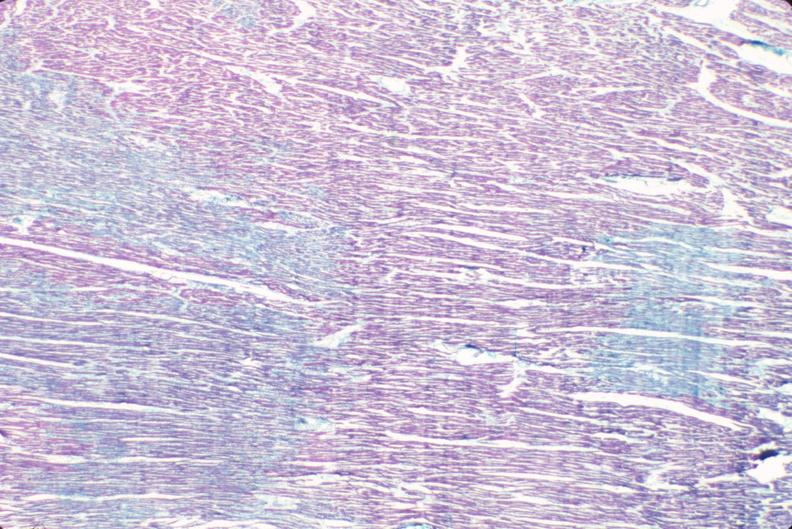what does this image show?
Answer the question using a single word or phrase. Heart 